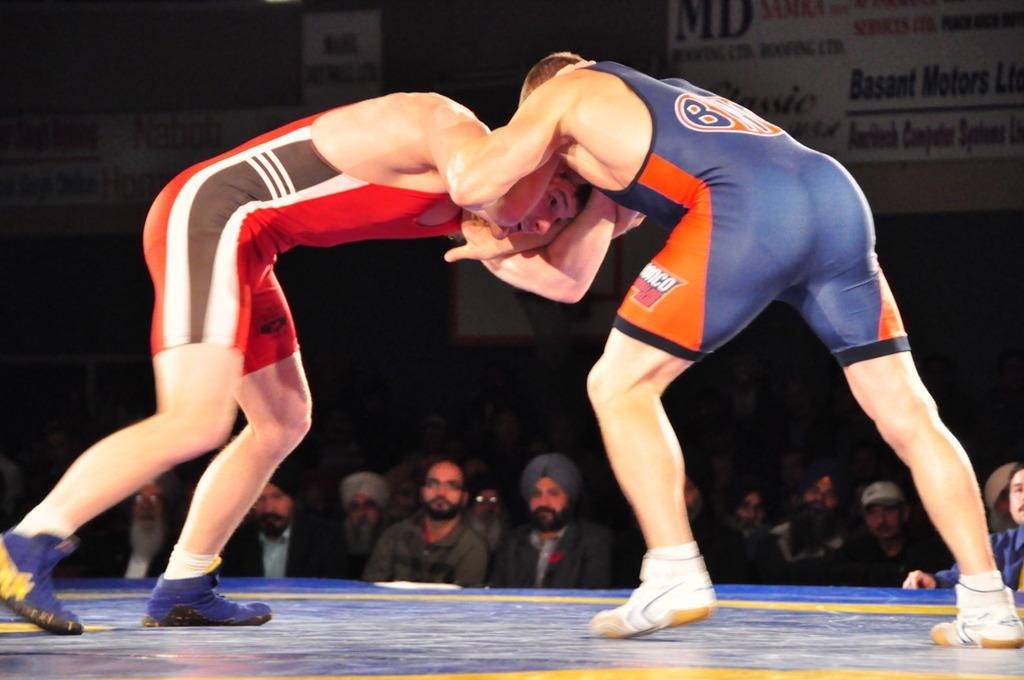<image>
Summarize the visual content of the image. a wrestler has the letter B on the back of their outfit 